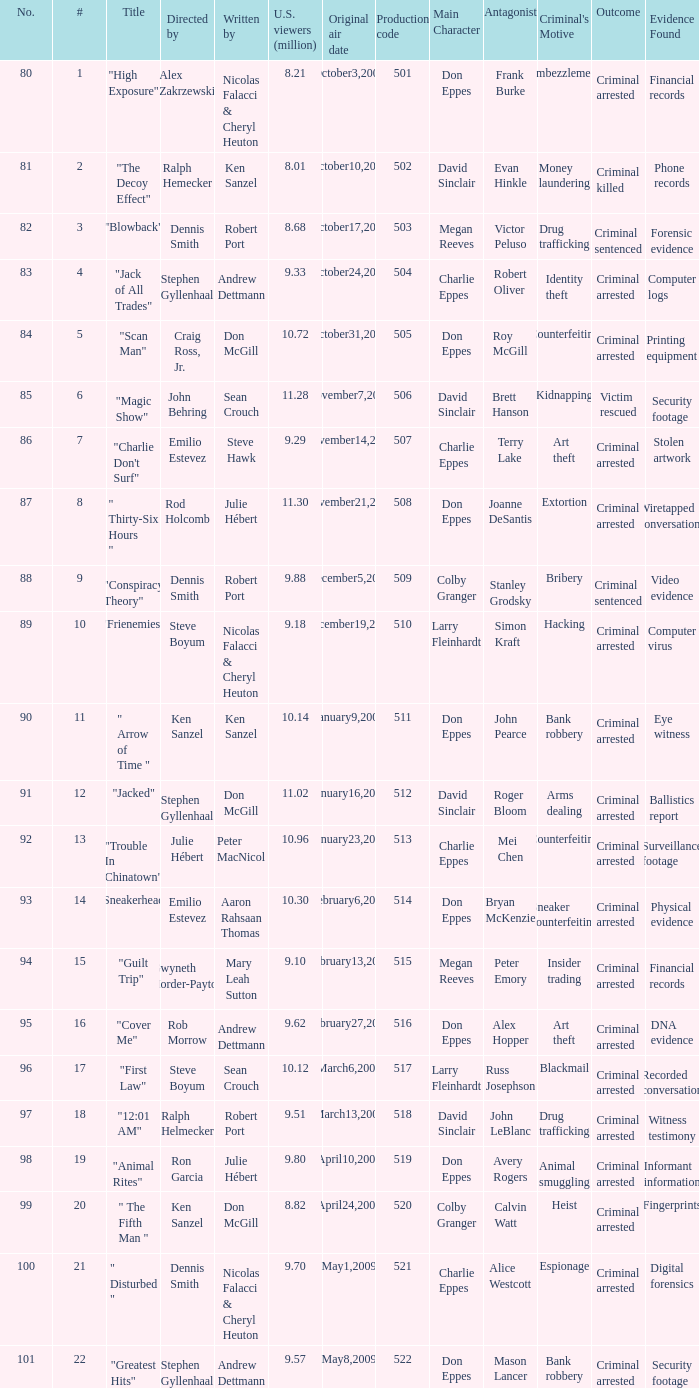Who wrote the episode with the production code 519? Julie Hébert. 